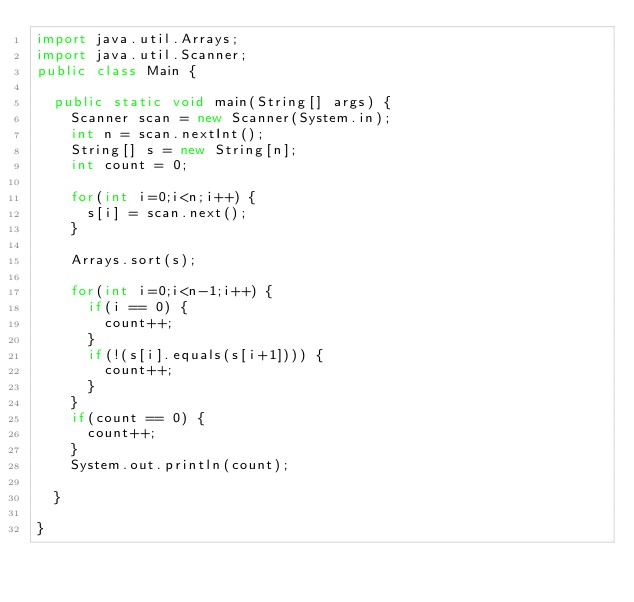<code> <loc_0><loc_0><loc_500><loc_500><_Java_>import java.util.Arrays;
import java.util.Scanner;
public class Main {

	public static void main(String[] args) {
		Scanner scan = new Scanner(System.in);
		int n = scan.nextInt();
		String[] s = new String[n];
		int count = 0;
		
		for(int i=0;i<n;i++) {
			s[i] = scan.next();
		}
		
		Arrays.sort(s);
		
		for(int i=0;i<n-1;i++) {
			if(i == 0) {
				count++;
			}
			if(!(s[i].equals(s[i+1]))) {
				count++;
			}
		}
		if(count == 0) {
			count++;
		}
		System.out.println(count);

	}

}</code> 